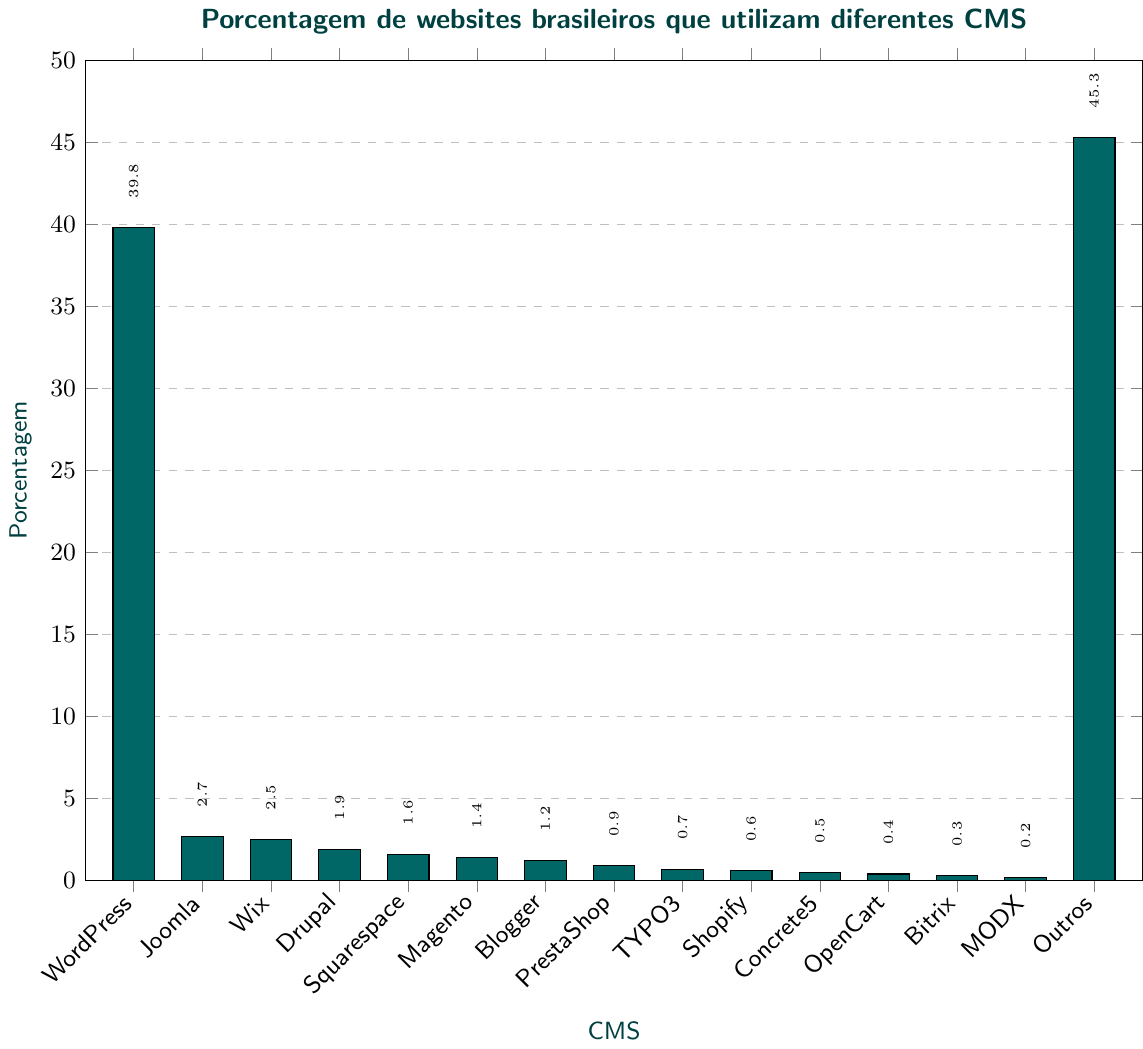Quais CMS têm porcentagens menores que 1%? A visualização mostra barras que representam a porcentagem de diversos CMS. Observando as barras com porcentagens menores que 1%, identificamos PrestaShop (0.9), TYPO3 (0.7), Shopify (0.6), Concrete5 (0.5), OpenCart (0.4), Bitrix (0.3) e MODX (0.2).
Answer: PrestaShop, TYPO3, Shopify, Concrete5, OpenCart, Bitrix, MODX Qual CMS tem a porcentagem mais alta? Observando a barra mais alta na visualização, vemos que o CMS com a maior porcentagem é o "Outros" com 45.3%.
Answer: Outros Qual é a diferença de porcentagem entre WordPress e Joomla? A barra de WordPress representa 39.8% e a de Joomla representa 2.7%. A diferença é 39.8 - 2.7 = 37.1.
Answer: 37.1 A soma das porcentagens de Wix, Drupal e Squarespace é maior que a de WordPress? Wix tem 2.5%, Drupal tem 1.9% e Squarespace tem 1.6%. Somando essas porcentagens: 2.5 + 1.9 + 1.6 = 6.0. 6.0 é menor que 39.8, a porcentagem de WordPress.
Answer: Não Qual CMS tem a menor porcentagem? Observando as barras, a menor porcentagem é do MODX com 0.2%.
Answer: MODX A soma das porcentagens de todos os CMS apresentados na figura resulta em mais de 100%? Somando todas as porcentagens: 39.8 (WordPress) + 2.7 (Joomla) + 2.5 (Wix) + 1.9 (Drupal) + 1.6 (Squarespace) + 1.4 (Magento) + 1.2 (Blogger) + 0.9 (PrestaShop) + 0.7 (TYPO3) + 0.6 (Shopify) + 0.5 (Concrete5) + 0.4 (OpenCart) + 0.3 (Bitrix) + 0.2 (MODX) + 45.3 (Outros) = 103.8.
Answer: Sim Qual é a diferença entre a porcentagem de WordPress e a soma das porcentagens de Drupal e Blogger? WordPress tem 39.8%, Drupal tem 1.9% e Blogger tem 1.2%. A diferença é 39.8 - (1.9 + 1.2) = 39.8 - 3.1 = 36.7.
Answer: 36.7 Quantos CMS diferentes têm porcentagens entre 0.5% e 2%? Observando as barras entre 0.5% e 2%, identificamos Drupal (1.9%), Squarespace (1.6%), Magento (1.4%), Blogger (1.2%), PrestaShop (0.9%), TYPO3 (0.7%) e Shopify (0.6%). Contando-os, obtemos 7.
Answer: 7 A porcentagem combinada de Joomla e Wix é maior que a de Outros? Joomla tem 2.7%, e Wix tem 2.5%. A soma é 2.7 + 2.5 = 5.2, que é menor que 45.3% de Outros.
Answer: Não 